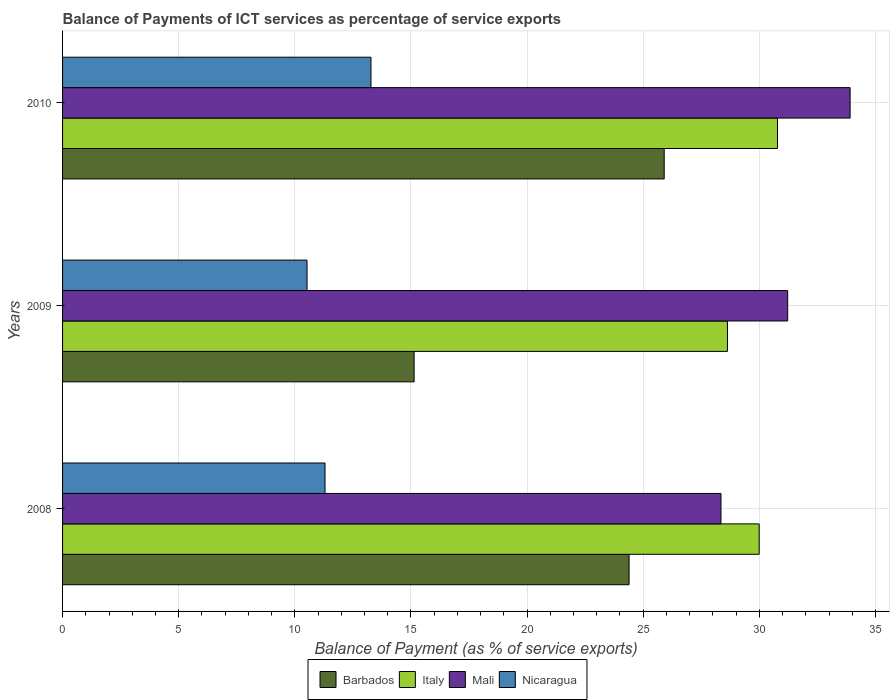How many different coloured bars are there?
Make the answer very short. 4. How many groups of bars are there?
Ensure brevity in your answer.  3. Are the number of bars per tick equal to the number of legend labels?
Your answer should be very brief. Yes. Are the number of bars on each tick of the Y-axis equal?
Your answer should be compact. Yes. How many bars are there on the 2nd tick from the top?
Provide a short and direct response. 4. In how many cases, is the number of bars for a given year not equal to the number of legend labels?
Your response must be concise. 0. What is the balance of payments of ICT services in Barbados in 2008?
Ensure brevity in your answer.  24.39. Across all years, what is the maximum balance of payments of ICT services in Barbados?
Provide a succinct answer. 25.9. Across all years, what is the minimum balance of payments of ICT services in Italy?
Offer a terse response. 28.63. What is the total balance of payments of ICT services in Barbados in the graph?
Your answer should be compact. 65.43. What is the difference between the balance of payments of ICT services in Mali in 2008 and that in 2010?
Your answer should be compact. -5.56. What is the difference between the balance of payments of ICT services in Mali in 2010 and the balance of payments of ICT services in Nicaragua in 2009?
Keep it short and to the point. 23.38. What is the average balance of payments of ICT services in Nicaragua per year?
Provide a succinct answer. 11.7. In the year 2009, what is the difference between the balance of payments of ICT services in Nicaragua and balance of payments of ICT services in Mali?
Give a very brief answer. -20.69. What is the ratio of the balance of payments of ICT services in Nicaragua in 2008 to that in 2009?
Provide a short and direct response. 1.07. Is the balance of payments of ICT services in Italy in 2008 less than that in 2009?
Ensure brevity in your answer.  No. What is the difference between the highest and the second highest balance of payments of ICT services in Mali?
Your answer should be very brief. 2.69. What is the difference between the highest and the lowest balance of payments of ICT services in Barbados?
Give a very brief answer. 10.77. Is the sum of the balance of payments of ICT services in Barbados in 2008 and 2009 greater than the maximum balance of payments of ICT services in Nicaragua across all years?
Make the answer very short. Yes. Is it the case that in every year, the sum of the balance of payments of ICT services in Barbados and balance of payments of ICT services in Mali is greater than the sum of balance of payments of ICT services in Italy and balance of payments of ICT services in Nicaragua?
Make the answer very short. No. What does the 2nd bar from the top in 2010 represents?
Your answer should be very brief. Mali. What does the 1st bar from the bottom in 2010 represents?
Make the answer very short. Barbados. Is it the case that in every year, the sum of the balance of payments of ICT services in Italy and balance of payments of ICT services in Mali is greater than the balance of payments of ICT services in Barbados?
Give a very brief answer. Yes. Are the values on the major ticks of X-axis written in scientific E-notation?
Make the answer very short. No. Does the graph contain any zero values?
Offer a terse response. No. How many legend labels are there?
Your answer should be very brief. 4. How are the legend labels stacked?
Give a very brief answer. Horizontal. What is the title of the graph?
Your answer should be compact. Balance of Payments of ICT services as percentage of service exports. What is the label or title of the X-axis?
Offer a terse response. Balance of Payment (as % of service exports). What is the label or title of the Y-axis?
Offer a very short reply. Years. What is the Balance of Payment (as % of service exports) in Barbados in 2008?
Your answer should be compact. 24.39. What is the Balance of Payment (as % of service exports) of Italy in 2008?
Provide a short and direct response. 29.99. What is the Balance of Payment (as % of service exports) of Mali in 2008?
Provide a short and direct response. 28.35. What is the Balance of Payment (as % of service exports) of Nicaragua in 2008?
Your answer should be very brief. 11.3. What is the Balance of Payment (as % of service exports) of Barbados in 2009?
Your response must be concise. 15.14. What is the Balance of Payment (as % of service exports) of Italy in 2009?
Offer a terse response. 28.63. What is the Balance of Payment (as % of service exports) in Mali in 2009?
Give a very brief answer. 31.22. What is the Balance of Payment (as % of service exports) in Nicaragua in 2009?
Keep it short and to the point. 10.53. What is the Balance of Payment (as % of service exports) in Barbados in 2010?
Keep it short and to the point. 25.9. What is the Balance of Payment (as % of service exports) of Italy in 2010?
Provide a short and direct response. 30.78. What is the Balance of Payment (as % of service exports) in Mali in 2010?
Your answer should be compact. 33.91. What is the Balance of Payment (as % of service exports) in Nicaragua in 2010?
Give a very brief answer. 13.28. Across all years, what is the maximum Balance of Payment (as % of service exports) of Barbados?
Ensure brevity in your answer.  25.9. Across all years, what is the maximum Balance of Payment (as % of service exports) in Italy?
Provide a short and direct response. 30.78. Across all years, what is the maximum Balance of Payment (as % of service exports) in Mali?
Make the answer very short. 33.91. Across all years, what is the maximum Balance of Payment (as % of service exports) of Nicaragua?
Offer a very short reply. 13.28. Across all years, what is the minimum Balance of Payment (as % of service exports) in Barbados?
Provide a short and direct response. 15.14. Across all years, what is the minimum Balance of Payment (as % of service exports) of Italy?
Provide a short and direct response. 28.63. Across all years, what is the minimum Balance of Payment (as % of service exports) of Mali?
Offer a very short reply. 28.35. Across all years, what is the minimum Balance of Payment (as % of service exports) of Nicaragua?
Ensure brevity in your answer.  10.53. What is the total Balance of Payment (as % of service exports) of Barbados in the graph?
Offer a terse response. 65.43. What is the total Balance of Payment (as % of service exports) of Italy in the graph?
Your answer should be compact. 89.4. What is the total Balance of Payment (as % of service exports) in Mali in the graph?
Your answer should be very brief. 93.48. What is the total Balance of Payment (as % of service exports) in Nicaragua in the graph?
Offer a terse response. 35.1. What is the difference between the Balance of Payment (as % of service exports) in Barbados in 2008 and that in 2009?
Your answer should be very brief. 9.26. What is the difference between the Balance of Payment (as % of service exports) in Italy in 2008 and that in 2009?
Give a very brief answer. 1.37. What is the difference between the Balance of Payment (as % of service exports) of Mali in 2008 and that in 2009?
Keep it short and to the point. -2.87. What is the difference between the Balance of Payment (as % of service exports) of Nicaragua in 2008 and that in 2009?
Give a very brief answer. 0.77. What is the difference between the Balance of Payment (as % of service exports) of Barbados in 2008 and that in 2010?
Make the answer very short. -1.51. What is the difference between the Balance of Payment (as % of service exports) in Italy in 2008 and that in 2010?
Give a very brief answer. -0.79. What is the difference between the Balance of Payment (as % of service exports) of Mali in 2008 and that in 2010?
Your answer should be very brief. -5.56. What is the difference between the Balance of Payment (as % of service exports) of Nicaragua in 2008 and that in 2010?
Provide a short and direct response. -1.98. What is the difference between the Balance of Payment (as % of service exports) in Barbados in 2009 and that in 2010?
Provide a succinct answer. -10.77. What is the difference between the Balance of Payment (as % of service exports) of Italy in 2009 and that in 2010?
Provide a short and direct response. -2.16. What is the difference between the Balance of Payment (as % of service exports) of Mali in 2009 and that in 2010?
Keep it short and to the point. -2.69. What is the difference between the Balance of Payment (as % of service exports) in Nicaragua in 2009 and that in 2010?
Offer a terse response. -2.75. What is the difference between the Balance of Payment (as % of service exports) in Barbados in 2008 and the Balance of Payment (as % of service exports) in Italy in 2009?
Ensure brevity in your answer.  -4.23. What is the difference between the Balance of Payment (as % of service exports) in Barbados in 2008 and the Balance of Payment (as % of service exports) in Mali in 2009?
Make the answer very short. -6.83. What is the difference between the Balance of Payment (as % of service exports) in Barbados in 2008 and the Balance of Payment (as % of service exports) in Nicaragua in 2009?
Your answer should be compact. 13.87. What is the difference between the Balance of Payment (as % of service exports) in Italy in 2008 and the Balance of Payment (as % of service exports) in Mali in 2009?
Your response must be concise. -1.23. What is the difference between the Balance of Payment (as % of service exports) of Italy in 2008 and the Balance of Payment (as % of service exports) of Nicaragua in 2009?
Offer a terse response. 19.47. What is the difference between the Balance of Payment (as % of service exports) in Mali in 2008 and the Balance of Payment (as % of service exports) in Nicaragua in 2009?
Make the answer very short. 17.82. What is the difference between the Balance of Payment (as % of service exports) of Barbados in 2008 and the Balance of Payment (as % of service exports) of Italy in 2010?
Provide a succinct answer. -6.39. What is the difference between the Balance of Payment (as % of service exports) of Barbados in 2008 and the Balance of Payment (as % of service exports) of Mali in 2010?
Offer a terse response. -9.52. What is the difference between the Balance of Payment (as % of service exports) in Barbados in 2008 and the Balance of Payment (as % of service exports) in Nicaragua in 2010?
Your answer should be very brief. 11.11. What is the difference between the Balance of Payment (as % of service exports) of Italy in 2008 and the Balance of Payment (as % of service exports) of Mali in 2010?
Your answer should be very brief. -3.92. What is the difference between the Balance of Payment (as % of service exports) in Italy in 2008 and the Balance of Payment (as % of service exports) in Nicaragua in 2010?
Make the answer very short. 16.71. What is the difference between the Balance of Payment (as % of service exports) of Mali in 2008 and the Balance of Payment (as % of service exports) of Nicaragua in 2010?
Keep it short and to the point. 15.07. What is the difference between the Balance of Payment (as % of service exports) in Barbados in 2009 and the Balance of Payment (as % of service exports) in Italy in 2010?
Give a very brief answer. -15.65. What is the difference between the Balance of Payment (as % of service exports) in Barbados in 2009 and the Balance of Payment (as % of service exports) in Mali in 2010?
Make the answer very short. -18.77. What is the difference between the Balance of Payment (as % of service exports) in Barbados in 2009 and the Balance of Payment (as % of service exports) in Nicaragua in 2010?
Ensure brevity in your answer.  1.86. What is the difference between the Balance of Payment (as % of service exports) in Italy in 2009 and the Balance of Payment (as % of service exports) in Mali in 2010?
Your answer should be very brief. -5.28. What is the difference between the Balance of Payment (as % of service exports) of Italy in 2009 and the Balance of Payment (as % of service exports) of Nicaragua in 2010?
Offer a very short reply. 15.35. What is the difference between the Balance of Payment (as % of service exports) of Mali in 2009 and the Balance of Payment (as % of service exports) of Nicaragua in 2010?
Offer a terse response. 17.94. What is the average Balance of Payment (as % of service exports) in Barbados per year?
Your response must be concise. 21.81. What is the average Balance of Payment (as % of service exports) in Italy per year?
Keep it short and to the point. 29.8. What is the average Balance of Payment (as % of service exports) of Mali per year?
Provide a short and direct response. 31.16. What is the average Balance of Payment (as % of service exports) of Nicaragua per year?
Ensure brevity in your answer.  11.7. In the year 2008, what is the difference between the Balance of Payment (as % of service exports) in Barbados and Balance of Payment (as % of service exports) in Italy?
Give a very brief answer. -5.6. In the year 2008, what is the difference between the Balance of Payment (as % of service exports) in Barbados and Balance of Payment (as % of service exports) in Mali?
Offer a terse response. -3.96. In the year 2008, what is the difference between the Balance of Payment (as % of service exports) in Barbados and Balance of Payment (as % of service exports) in Nicaragua?
Provide a succinct answer. 13.09. In the year 2008, what is the difference between the Balance of Payment (as % of service exports) of Italy and Balance of Payment (as % of service exports) of Mali?
Give a very brief answer. 1.64. In the year 2008, what is the difference between the Balance of Payment (as % of service exports) in Italy and Balance of Payment (as % of service exports) in Nicaragua?
Your answer should be very brief. 18.69. In the year 2008, what is the difference between the Balance of Payment (as % of service exports) of Mali and Balance of Payment (as % of service exports) of Nicaragua?
Your answer should be very brief. 17.05. In the year 2009, what is the difference between the Balance of Payment (as % of service exports) of Barbados and Balance of Payment (as % of service exports) of Italy?
Your response must be concise. -13.49. In the year 2009, what is the difference between the Balance of Payment (as % of service exports) of Barbados and Balance of Payment (as % of service exports) of Mali?
Your answer should be compact. -16.08. In the year 2009, what is the difference between the Balance of Payment (as % of service exports) of Barbados and Balance of Payment (as % of service exports) of Nicaragua?
Ensure brevity in your answer.  4.61. In the year 2009, what is the difference between the Balance of Payment (as % of service exports) of Italy and Balance of Payment (as % of service exports) of Mali?
Give a very brief answer. -2.59. In the year 2009, what is the difference between the Balance of Payment (as % of service exports) of Italy and Balance of Payment (as % of service exports) of Nicaragua?
Give a very brief answer. 18.1. In the year 2009, what is the difference between the Balance of Payment (as % of service exports) of Mali and Balance of Payment (as % of service exports) of Nicaragua?
Keep it short and to the point. 20.69. In the year 2010, what is the difference between the Balance of Payment (as % of service exports) in Barbados and Balance of Payment (as % of service exports) in Italy?
Offer a terse response. -4.88. In the year 2010, what is the difference between the Balance of Payment (as % of service exports) of Barbados and Balance of Payment (as % of service exports) of Mali?
Your answer should be compact. -8. In the year 2010, what is the difference between the Balance of Payment (as % of service exports) of Barbados and Balance of Payment (as % of service exports) of Nicaragua?
Provide a succinct answer. 12.62. In the year 2010, what is the difference between the Balance of Payment (as % of service exports) of Italy and Balance of Payment (as % of service exports) of Mali?
Provide a short and direct response. -3.13. In the year 2010, what is the difference between the Balance of Payment (as % of service exports) in Italy and Balance of Payment (as % of service exports) in Nicaragua?
Your answer should be compact. 17.5. In the year 2010, what is the difference between the Balance of Payment (as % of service exports) of Mali and Balance of Payment (as % of service exports) of Nicaragua?
Your response must be concise. 20.63. What is the ratio of the Balance of Payment (as % of service exports) of Barbados in 2008 to that in 2009?
Provide a succinct answer. 1.61. What is the ratio of the Balance of Payment (as % of service exports) of Italy in 2008 to that in 2009?
Offer a terse response. 1.05. What is the ratio of the Balance of Payment (as % of service exports) of Mali in 2008 to that in 2009?
Keep it short and to the point. 0.91. What is the ratio of the Balance of Payment (as % of service exports) of Nicaragua in 2008 to that in 2009?
Offer a terse response. 1.07. What is the ratio of the Balance of Payment (as % of service exports) of Barbados in 2008 to that in 2010?
Your answer should be compact. 0.94. What is the ratio of the Balance of Payment (as % of service exports) in Italy in 2008 to that in 2010?
Provide a succinct answer. 0.97. What is the ratio of the Balance of Payment (as % of service exports) in Mali in 2008 to that in 2010?
Give a very brief answer. 0.84. What is the ratio of the Balance of Payment (as % of service exports) of Nicaragua in 2008 to that in 2010?
Your answer should be compact. 0.85. What is the ratio of the Balance of Payment (as % of service exports) of Barbados in 2009 to that in 2010?
Give a very brief answer. 0.58. What is the ratio of the Balance of Payment (as % of service exports) in Italy in 2009 to that in 2010?
Provide a short and direct response. 0.93. What is the ratio of the Balance of Payment (as % of service exports) of Mali in 2009 to that in 2010?
Provide a short and direct response. 0.92. What is the ratio of the Balance of Payment (as % of service exports) in Nicaragua in 2009 to that in 2010?
Your response must be concise. 0.79. What is the difference between the highest and the second highest Balance of Payment (as % of service exports) of Barbados?
Your answer should be very brief. 1.51. What is the difference between the highest and the second highest Balance of Payment (as % of service exports) in Italy?
Give a very brief answer. 0.79. What is the difference between the highest and the second highest Balance of Payment (as % of service exports) in Mali?
Ensure brevity in your answer.  2.69. What is the difference between the highest and the second highest Balance of Payment (as % of service exports) of Nicaragua?
Provide a succinct answer. 1.98. What is the difference between the highest and the lowest Balance of Payment (as % of service exports) of Barbados?
Provide a short and direct response. 10.77. What is the difference between the highest and the lowest Balance of Payment (as % of service exports) in Italy?
Your answer should be compact. 2.16. What is the difference between the highest and the lowest Balance of Payment (as % of service exports) in Mali?
Ensure brevity in your answer.  5.56. What is the difference between the highest and the lowest Balance of Payment (as % of service exports) of Nicaragua?
Offer a terse response. 2.75. 